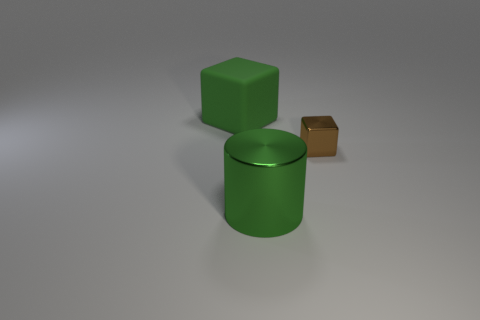Add 1 tiny brown cubes. How many tiny brown cubes exist? 2 Add 2 purple cylinders. How many objects exist? 5 Subtract all brown blocks. How many blocks are left? 1 Subtract 0 yellow cylinders. How many objects are left? 3 Subtract all blocks. How many objects are left? 1 Subtract all gray cubes. Subtract all red cylinders. How many cubes are left? 2 Subtract all cyan spheres. How many brown cubes are left? 1 Subtract all yellow matte things. Subtract all big green metal cylinders. How many objects are left? 2 Add 3 large rubber blocks. How many large rubber blocks are left? 4 